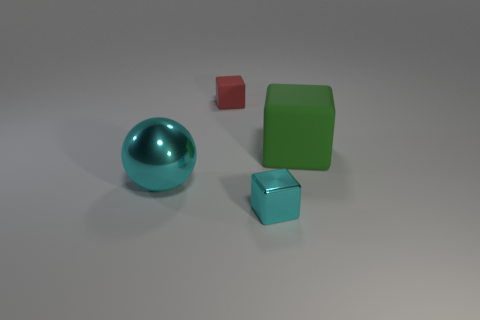How many matte blocks are the same color as the small shiny thing?
Your answer should be compact. 0. The other block that is the same material as the red cube is what size?
Keep it short and to the point. Large. What number of brown things are tiny rubber blocks or spheres?
Ensure brevity in your answer.  0. What number of large cyan metal objects are to the right of the small block in front of the large green matte object?
Provide a succinct answer. 0. Is the number of small matte objects to the right of the big cyan metal thing greater than the number of cubes left of the red block?
Offer a very short reply. Yes. What material is the cyan ball?
Make the answer very short. Metal. Is there another cyan sphere that has the same size as the cyan sphere?
Give a very brief answer. No. There is a cube that is the same size as the red object; what is it made of?
Provide a succinct answer. Metal. What number of green matte cubes are there?
Provide a short and direct response. 1. What size is the matte cube that is in front of the small red matte cube?
Ensure brevity in your answer.  Large. 